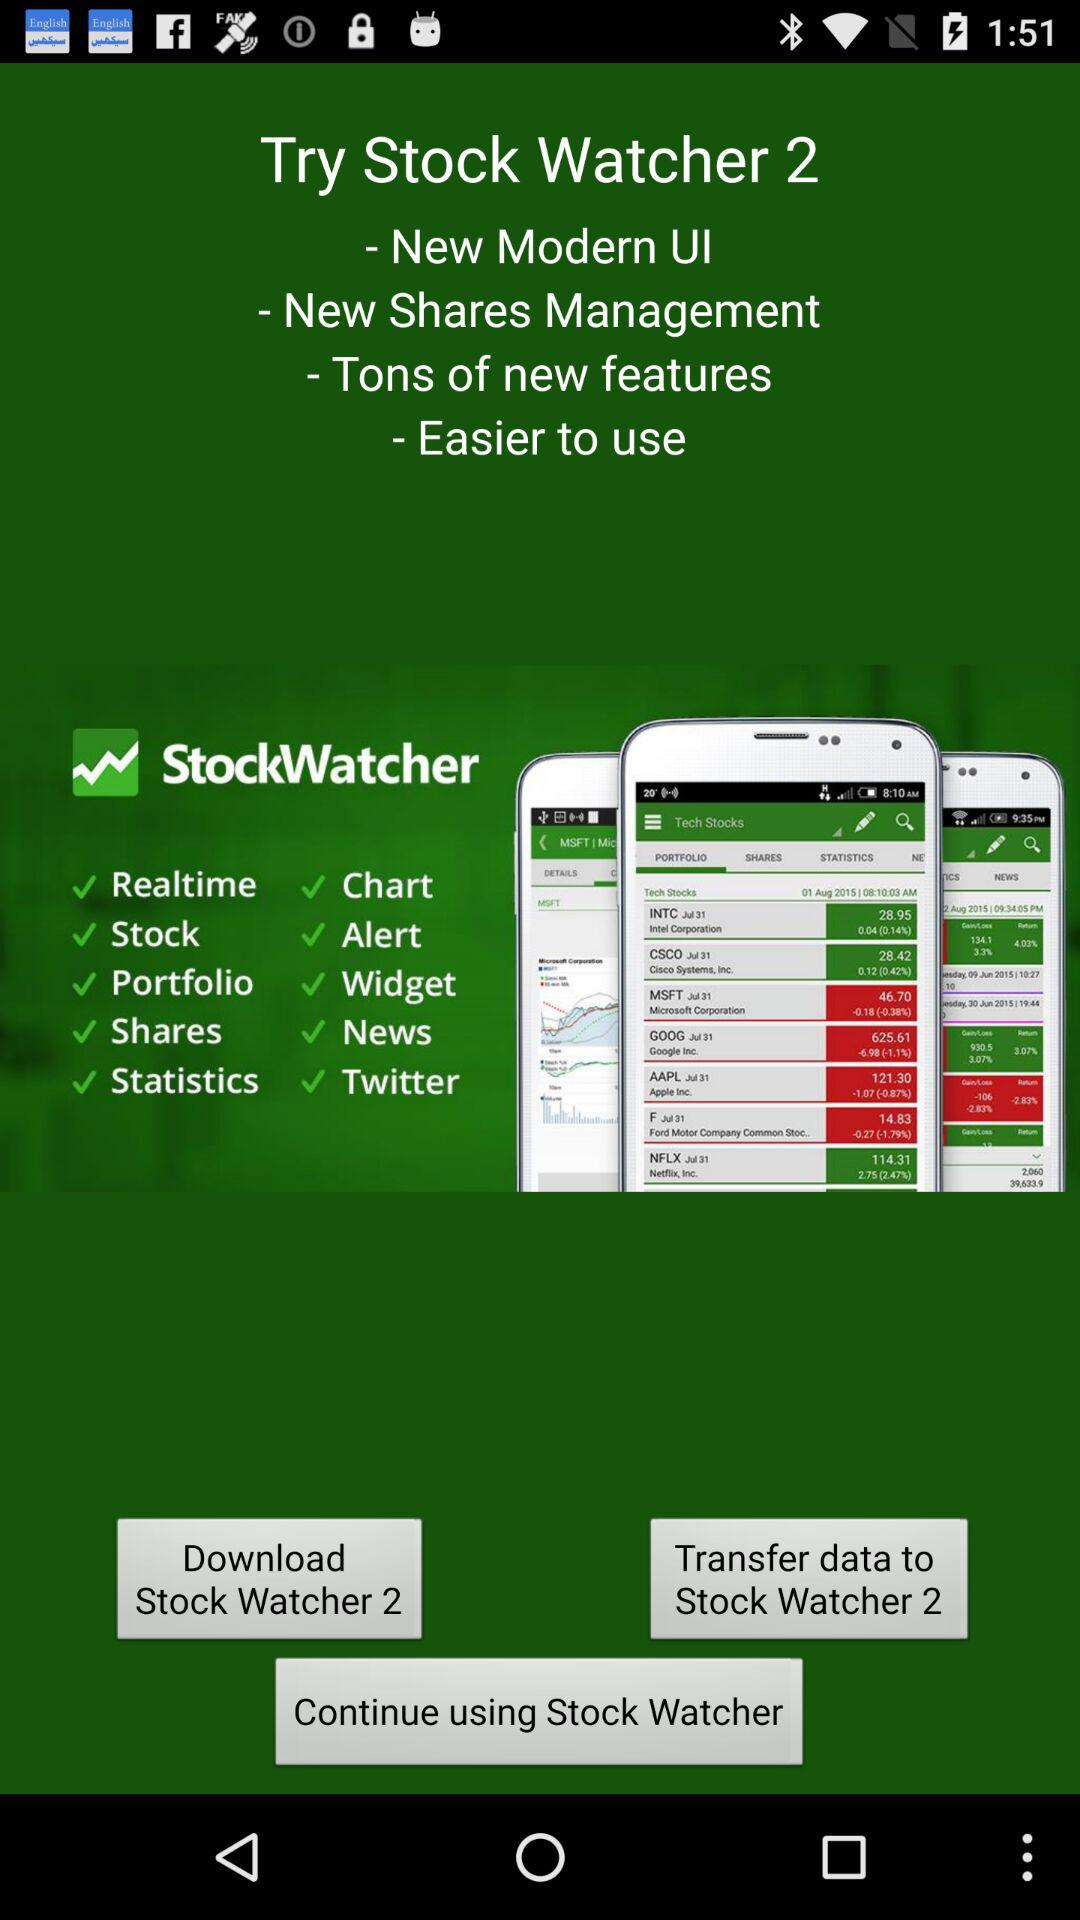What is the name of the application? The name of the application is "Stock Watcher 2". 